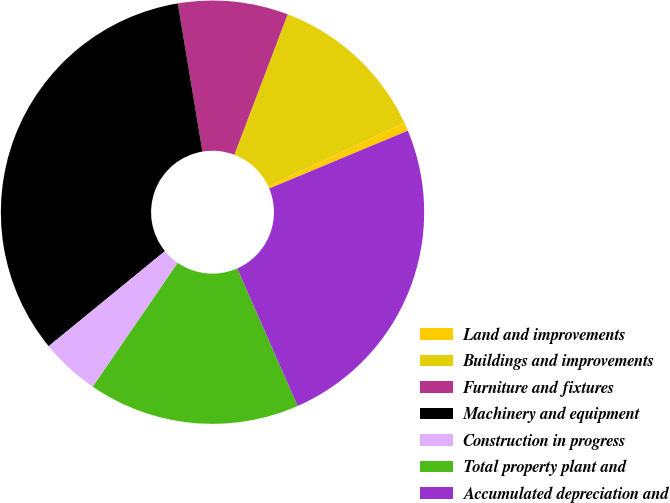Convert chart. <chart><loc_0><loc_0><loc_500><loc_500><pie_chart><fcel>Land and improvements<fcel>Buildings and improvements<fcel>Furniture and fixtures<fcel>Machinery and equipment<fcel>Construction in progress<fcel>Total property plant and<fcel>Accumulated depreciation and<nl><fcel>0.65%<fcel>12.28%<fcel>8.4%<fcel>33.29%<fcel>4.52%<fcel>16.16%<fcel>24.7%<nl></chart> 